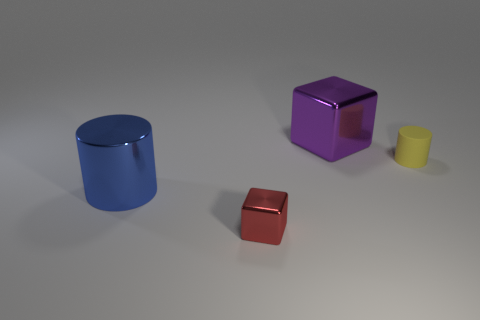Add 1 small blocks. How many objects exist? 5 Add 1 small rubber cylinders. How many small rubber cylinders exist? 2 Subtract 0 cyan cylinders. How many objects are left? 4 Subtract all large purple objects. Subtract all small purple rubber cubes. How many objects are left? 3 Add 1 purple cubes. How many purple cubes are left? 2 